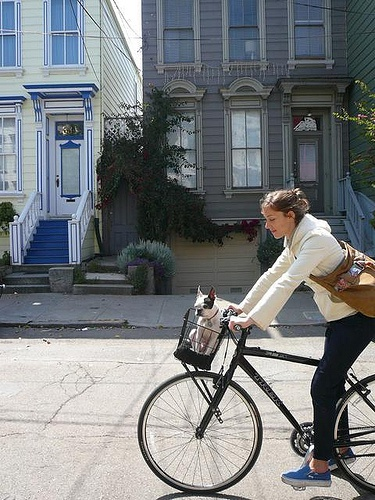Describe the objects in this image and their specific colors. I can see bicycle in lavender, lightgray, black, darkgray, and gray tones, people in lavender, black, darkgray, lightgray, and tan tones, handbag in lavender, maroon, gray, and black tones, and dog in lavender, darkgray, gray, white, and black tones in this image. 